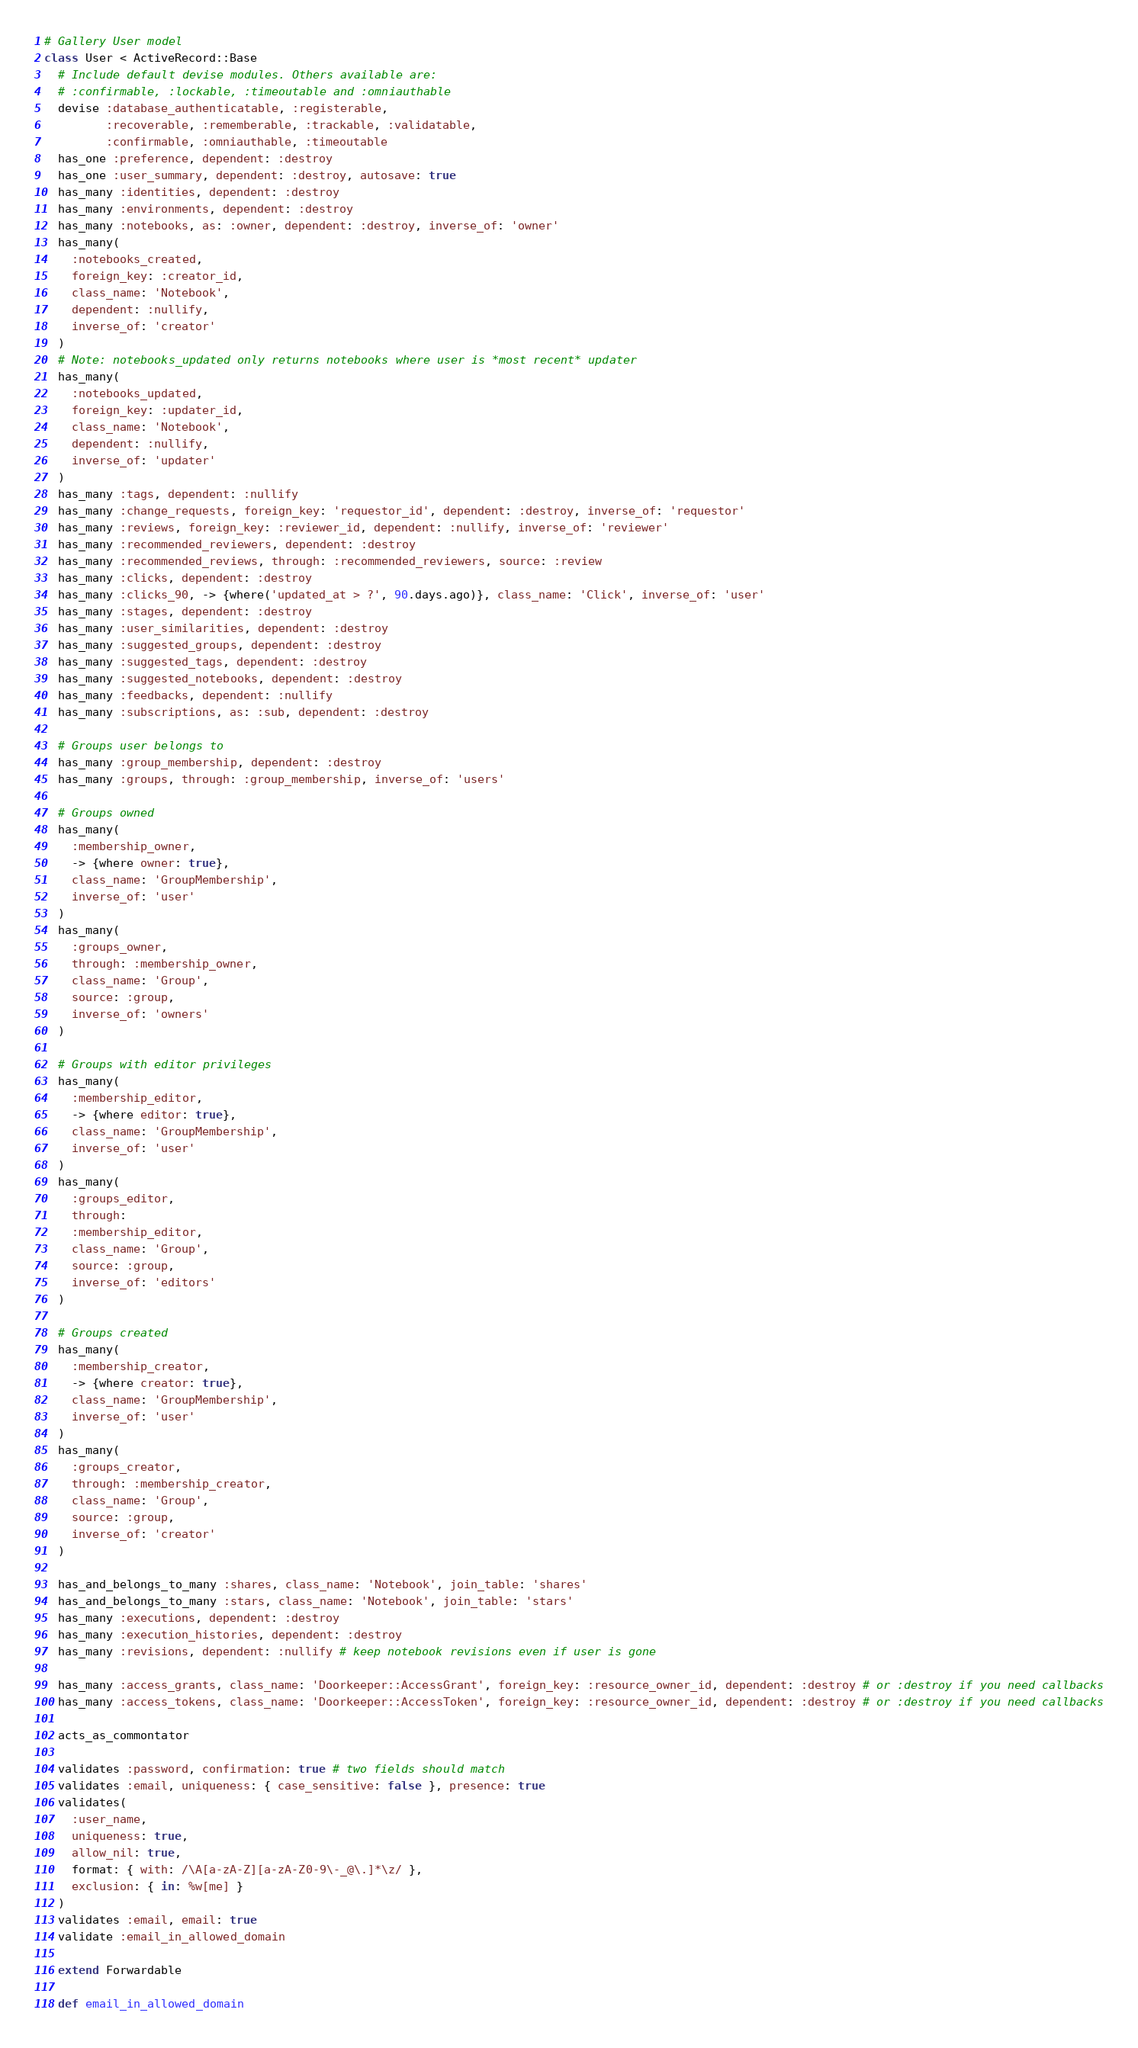<code> <loc_0><loc_0><loc_500><loc_500><_Ruby_># Gallery User model
class User < ActiveRecord::Base
  # Include default devise modules. Others available are:
  # :confirmable, :lockable, :timeoutable and :omniauthable
  devise :database_authenticatable, :registerable,
         :recoverable, :rememberable, :trackable, :validatable,
         :confirmable, :omniauthable, :timeoutable
  has_one :preference, dependent: :destroy
  has_one :user_summary, dependent: :destroy, autosave: true
  has_many :identities, dependent: :destroy
  has_many :environments, dependent: :destroy
  has_many :notebooks, as: :owner, dependent: :destroy, inverse_of: 'owner'
  has_many(
    :notebooks_created,
    foreign_key: :creator_id,
    class_name: 'Notebook',
    dependent: :nullify,
    inverse_of: 'creator'
  )
  # Note: notebooks_updated only returns notebooks where user is *most recent* updater
  has_many(
    :notebooks_updated,
    foreign_key: :updater_id,
    class_name: 'Notebook',
    dependent: :nullify,
    inverse_of: 'updater'
  )
  has_many :tags, dependent: :nullify
  has_many :change_requests, foreign_key: 'requestor_id', dependent: :destroy, inverse_of: 'requestor'
  has_many :reviews, foreign_key: :reviewer_id, dependent: :nullify, inverse_of: 'reviewer'
  has_many :recommended_reviewers, dependent: :destroy
  has_many :recommended_reviews, through: :recommended_reviewers, source: :review
  has_many :clicks, dependent: :destroy
  has_many :clicks_90, -> {where('updated_at > ?', 90.days.ago)}, class_name: 'Click', inverse_of: 'user'
  has_many :stages, dependent: :destroy
  has_many :user_similarities, dependent: :destroy
  has_many :suggested_groups, dependent: :destroy
  has_many :suggested_tags, dependent: :destroy
  has_many :suggested_notebooks, dependent: :destroy
  has_many :feedbacks, dependent: :nullify
  has_many :subscriptions, as: :sub, dependent: :destroy

  # Groups user belongs to
  has_many :group_membership, dependent: :destroy
  has_many :groups, through: :group_membership, inverse_of: 'users'

  # Groups owned
  has_many(
    :membership_owner,
    -> {where owner: true},
    class_name: 'GroupMembership',
    inverse_of: 'user'
  )
  has_many(
    :groups_owner,
    through: :membership_owner,
    class_name: 'Group',
    source: :group,
    inverse_of: 'owners'
  )

  # Groups with editor privileges
  has_many(
    :membership_editor,
    -> {where editor: true},
    class_name: 'GroupMembership',
    inverse_of: 'user'
  )
  has_many(
    :groups_editor,
    through:
    :membership_editor,
    class_name: 'Group',
    source: :group,
    inverse_of: 'editors'
  )

  # Groups created
  has_many(
    :membership_creator,
    -> {where creator: true},
    class_name: 'GroupMembership',
    inverse_of: 'user'
  )
  has_many(
    :groups_creator,
    through: :membership_creator,
    class_name: 'Group',
    source: :group,
    inverse_of: 'creator'
  )

  has_and_belongs_to_many :shares, class_name: 'Notebook', join_table: 'shares'
  has_and_belongs_to_many :stars, class_name: 'Notebook', join_table: 'stars'
  has_many :executions, dependent: :destroy
  has_many :execution_histories, dependent: :destroy
  has_many :revisions, dependent: :nullify # keep notebook revisions even if user is gone

  has_many :access_grants, class_name: 'Doorkeeper::AccessGrant', foreign_key: :resource_owner_id, dependent: :destroy # or :destroy if you need callbacks
  has_many :access_tokens, class_name: 'Doorkeeper::AccessToken', foreign_key: :resource_owner_id, dependent: :destroy # or :destroy if you need callbacks

  acts_as_commontator

  validates :password, confirmation: true # two fields should match
  validates :email, uniqueness: { case_sensitive: false }, presence: true
  validates(
    :user_name,
    uniqueness: true,
    allow_nil: true,
    format: { with: /\A[a-zA-Z][a-zA-Z0-9\-_@\.]*\z/ },
    exclusion: { in: %w[me] }
  )
  validates :email, email: true
  validate :email_in_allowed_domain

  extend Forwardable

  def email_in_allowed_domain</code> 